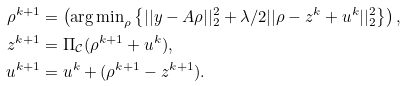Convert formula to latex. <formula><loc_0><loc_0><loc_500><loc_500>\rho ^ { k + 1 } & = \left ( { \arg \min } _ { \rho } \left \{ | | y - A \rho | | _ { 2 } ^ { 2 } + \lambda / 2 | | \rho - z ^ { k } + u ^ { k } | | _ { 2 } ^ { 2 } \right \} \right ) , \\ z ^ { k + 1 } & = \Pi _ { \mathcal { C } } ( \rho ^ { k + 1 } + u ^ { k } ) , \\ u ^ { k + 1 } & = u ^ { k } + ( \rho ^ { k + 1 } - z ^ { k + 1 } ) .</formula> 